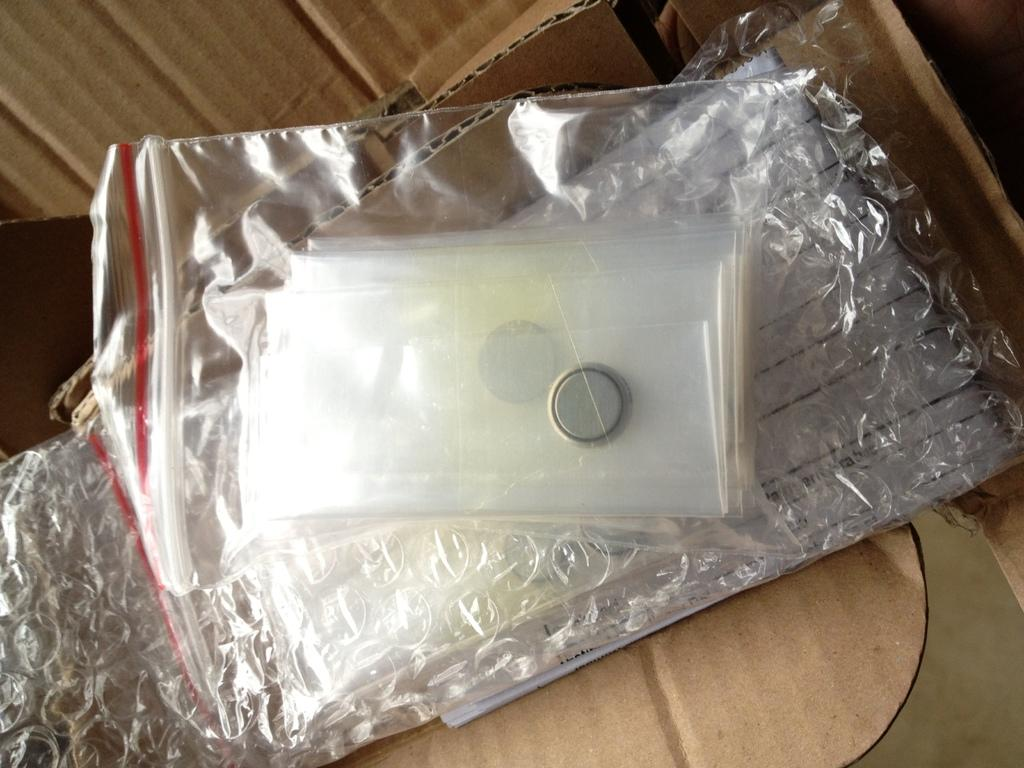What material is the main object in the image made of? The main object in the image is made of cardboard. What other material is present in the image? Plastic is also present in the image. What type of sheet is visible in the image? There is a bubble sheet in the image. Where is the battery located in the image? The battery is in the middle of the image. How many chairs can be seen in the image? There are no chairs present in the image. What type of respect is shown in the image? The image does not depict any specific type of respect; it features a cardboard sheet, plastic, a bubble sheet, and a battery. 